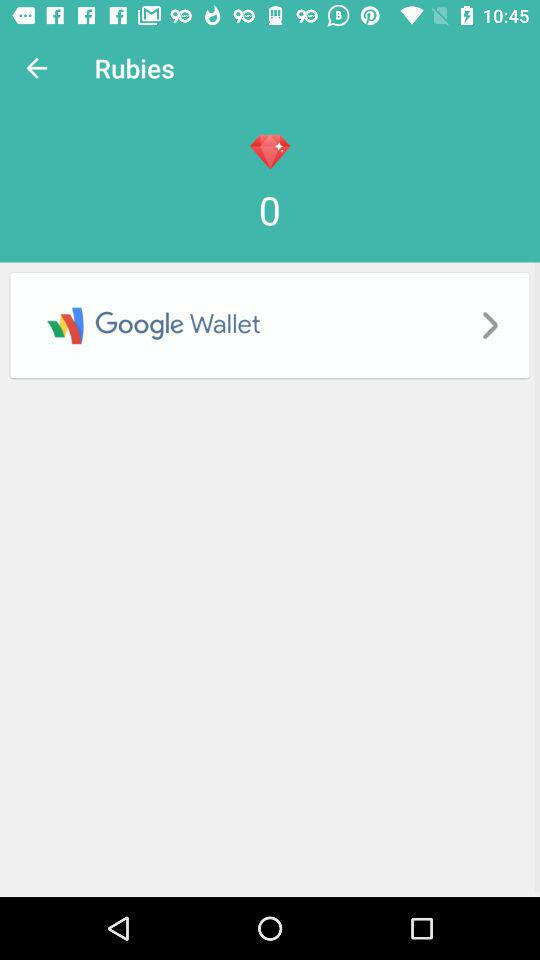How many rubies are there? There are 0 rubies. 